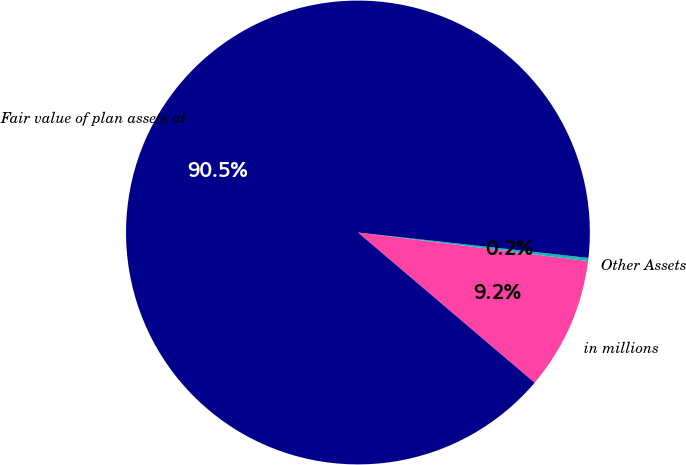Convert chart. <chart><loc_0><loc_0><loc_500><loc_500><pie_chart><fcel>in millions<fcel>Other Assets<fcel>Fair value of plan assets at<nl><fcel>9.25%<fcel>0.22%<fcel>90.53%<nl></chart> 